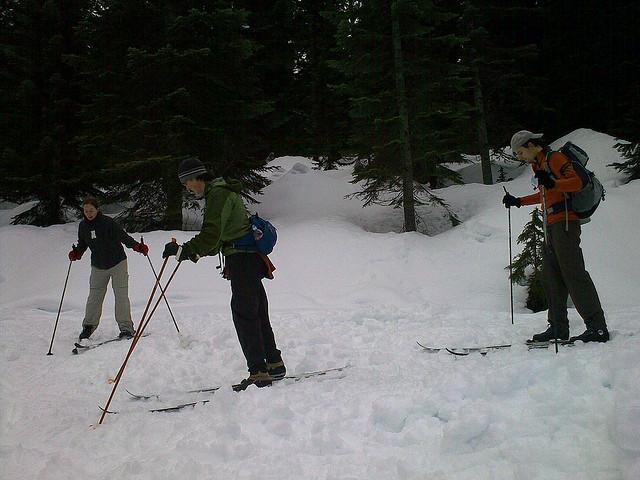How many people are in this photo?
Give a very brief answer. 3. How many people are skiing?
Give a very brief answer. 3. How many skies are there?
Give a very brief answer. 6. How many ski can be seen?
Give a very brief answer. 1. How many people are in the photo?
Give a very brief answer. 3. How many cat balloons are there?
Give a very brief answer. 0. 